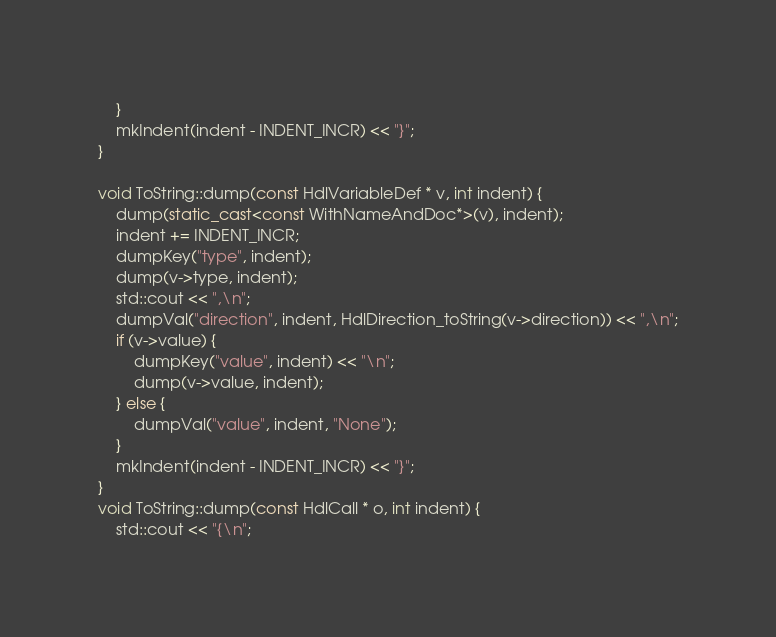<code> <loc_0><loc_0><loc_500><loc_500><_C++_>	}
	mkIndent(indent - INDENT_INCR) << "}";
}

void ToString::dump(const HdlVariableDef * v, int indent) {
	dump(static_cast<const WithNameAndDoc*>(v), indent);
	indent += INDENT_INCR;
	dumpKey("type", indent);
	dump(v->type, indent);
	std::cout << ",\n";
	dumpVal("direction", indent, HdlDirection_toString(v->direction)) << ",\n";
	if (v->value) {
		dumpKey("value", indent) << "\n";
		dump(v->value, indent);
	} else {
		dumpVal("value", indent, "None");
	}
	mkIndent(indent - INDENT_INCR) << "}";
}
void ToString::dump(const HdlCall * o, int indent) {
	std::cout << "{\n";</code> 